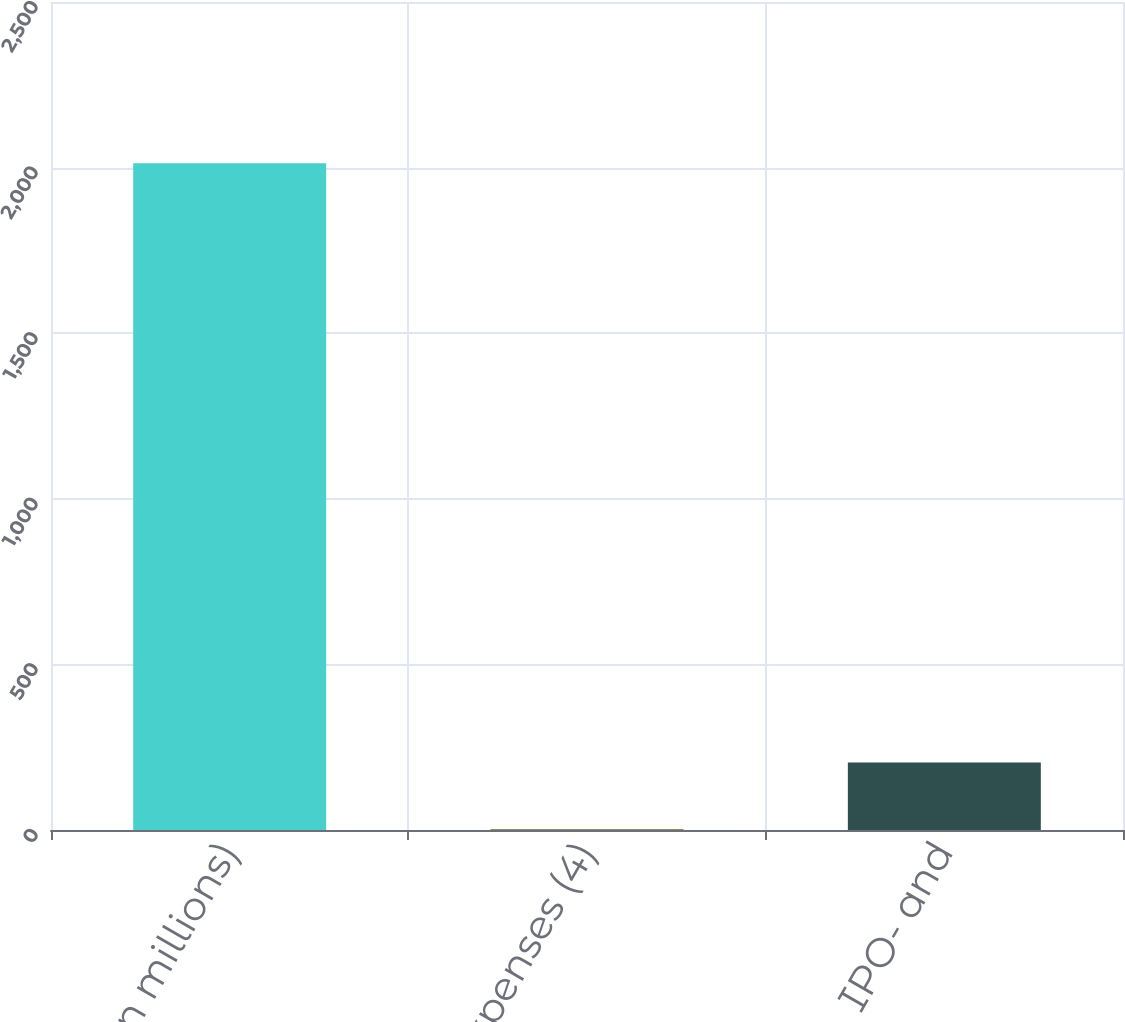Convert chart to OTSL. <chart><loc_0><loc_0><loc_500><loc_500><bar_chart><fcel>(in millions)<fcel>Other expenses (4)<fcel>IPO- and<nl><fcel>2013<fcel>2.4<fcel>203.46<nl></chart> 